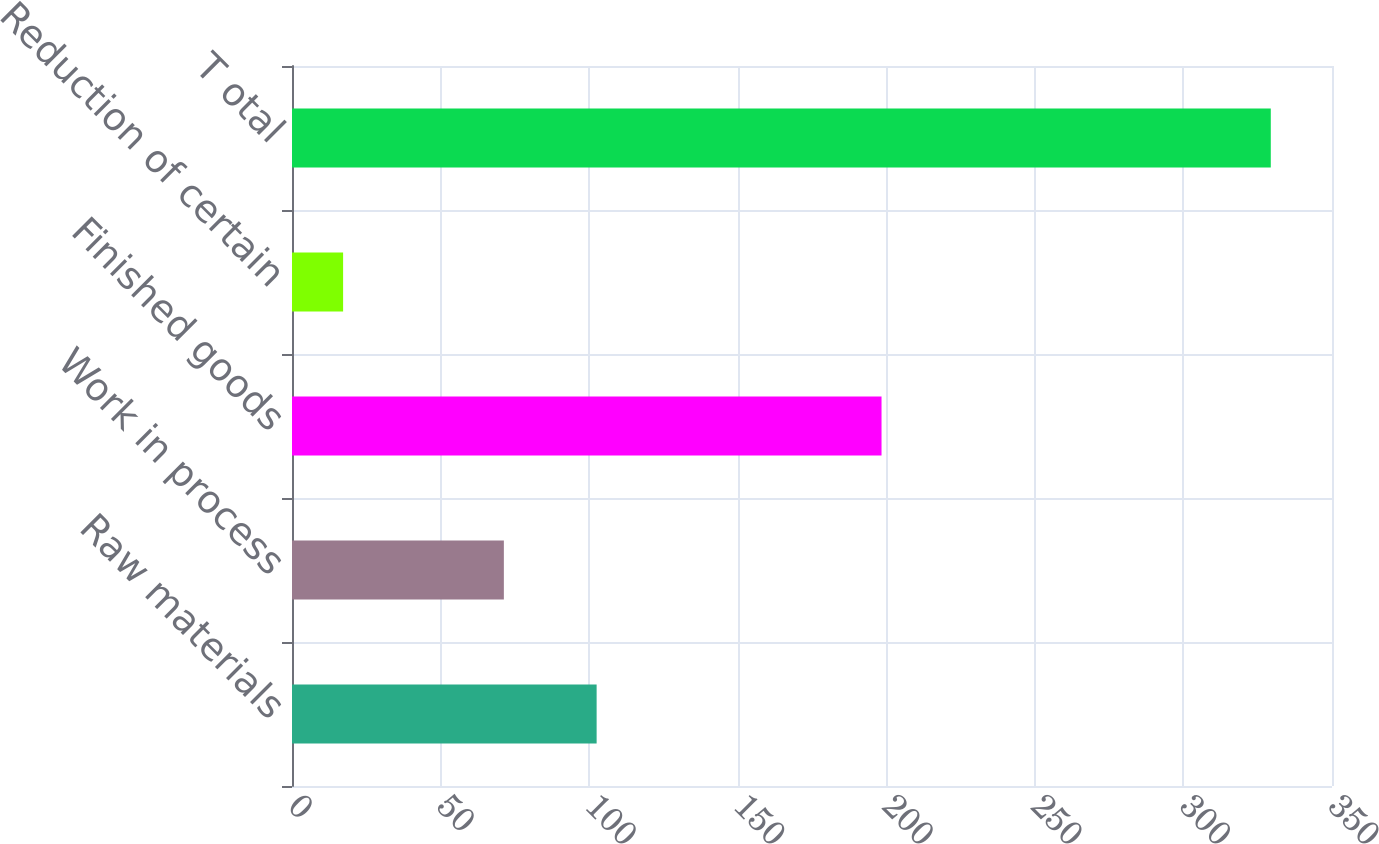<chart> <loc_0><loc_0><loc_500><loc_500><bar_chart><fcel>Raw materials<fcel>Work in process<fcel>Finished goods<fcel>Reduction of certain<fcel>T otal<nl><fcel>102.52<fcel>71.3<fcel>198.4<fcel>17.2<fcel>329.4<nl></chart> 